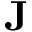<formula> <loc_0><loc_0><loc_500><loc_500>J</formula> 